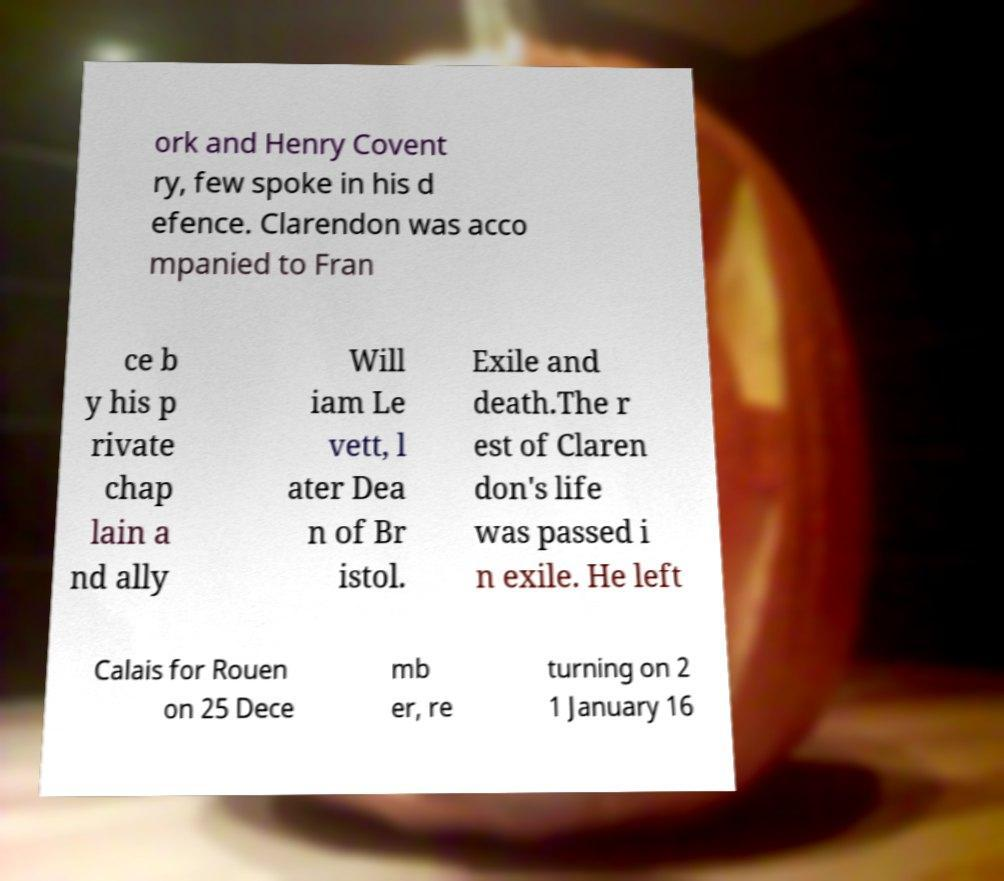Can you accurately transcribe the text from the provided image for me? ork and Henry Covent ry, few spoke in his d efence. Clarendon was acco mpanied to Fran ce b y his p rivate chap lain a nd ally Will iam Le vett, l ater Dea n of Br istol. Exile and death.The r est of Claren don's life was passed i n exile. He left Calais for Rouen on 25 Dece mb er, re turning on 2 1 January 16 